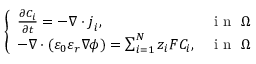<formula> <loc_0><loc_0><loc_500><loc_500>\left \{ \begin{array} { l l } { \frac { \partial C _ { i } } { \partial t } = - \nabla \cdot j _ { i } , } & { i n \Omega } \\ { - \nabla \cdot ( \varepsilon _ { 0 } \varepsilon _ { r } \nabla \phi ) = \sum _ { i = 1 } ^ { N } z _ { i } F C _ { i } , } & { i n \Omega } \end{array}</formula> 